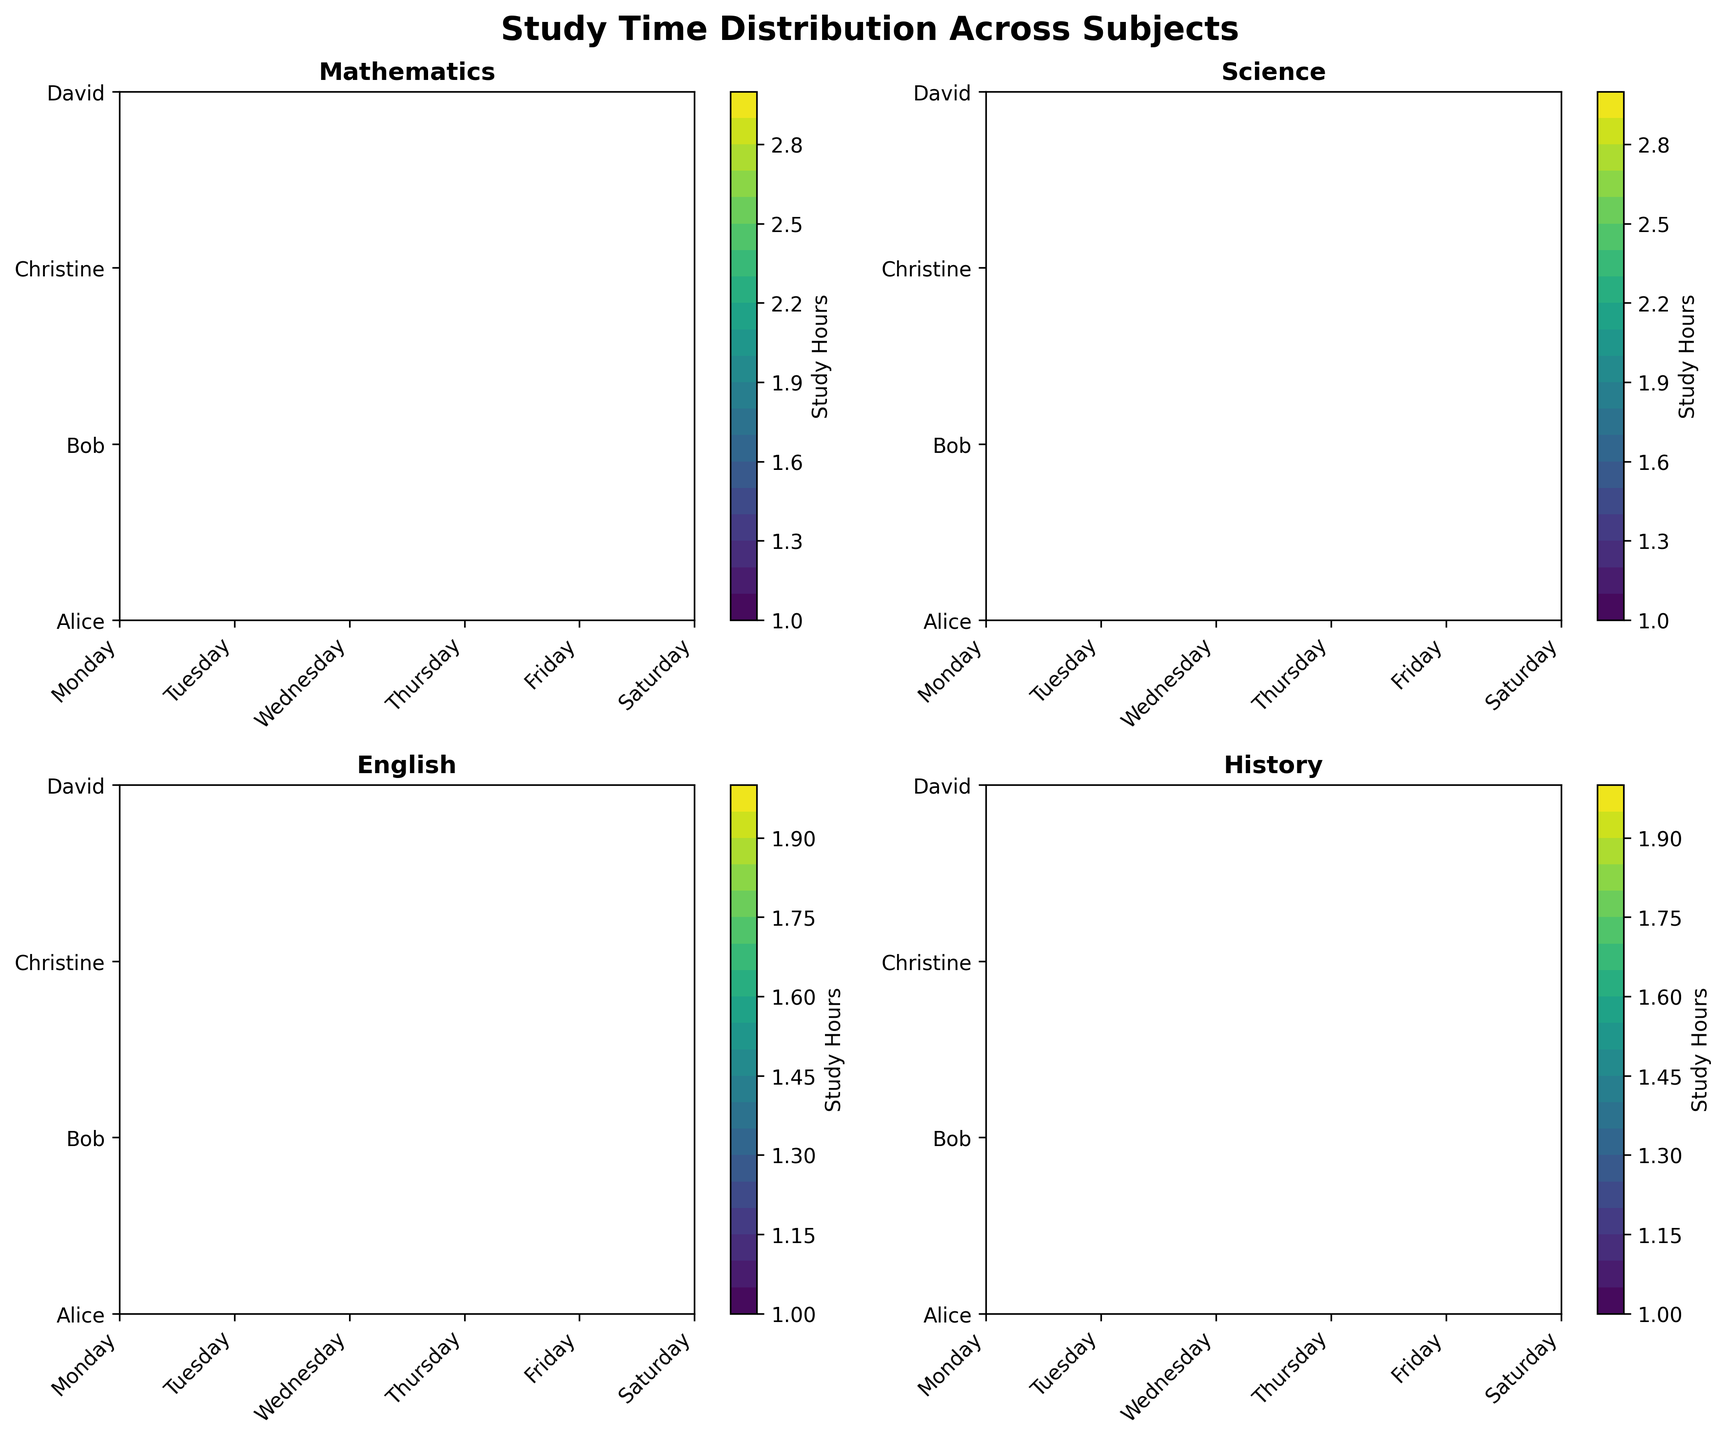What is the title of the figure? The title is usually placed at the top of the figure. Here, we can see that it says "Study Time Distribution Across Subjects," indicating the topic of the figure
Answer: Study Time Distribution Across Subjects Which subject panel has the highest study hours on Monday for the most students? By observing the contour intensity in the Monday column across all subject panels, we can identify which subject has the highest contour value. In this case, both Mathematics and Science panels have high study hours on Monday for multiple students
Answer: Mathematics and Science How many subjects are depicted in the figure? Each subplot shows a different subject, and there are four subplots. By counting these subplots, we conclude that there are four subjects represented
Answer: Four In which subject is the study time distribution the most uniform across the days? We need to look at the contour plots and see where the contour lines are most evenly spaced and the color distribution is consistent. The Mathematics panel looks the most uniform in terms of color and spacing
Answer: Mathematics Which subject shows the highest variability in study hours among students? By examining the contour plots, we can detect variability through inconsistencies and variations in the contour levels. History seems to have more variability in study hours based on the contour data
Answer: History Who studied the least amount of hours for English on Friday? We need to look at the English panel and find the contour values for Friday. By checking the contour levels associated with each student, we can see Christine studied the least amount of hours
Answer: Christine Which student has the most consistent study hours across all days for Science? By comparing the rows in the Science panel, we need to find the student whose contour levels are relatively flat and uniform across the days. Alice demonstrates the most consistent study hours
Answer: Alice On which day did Alice study Mathematics the longest? To answer this, observe the Mathematics panel and track Alice's row for the highest value. She studied the longest (2 hours) on Monday and Saturday
Answer: Monday and Saturday Which student dedicated the most hours to History on Tuesday? By examining the History panel and identifying which student has the highest contour level for Tuesday, we find that Bob dedicated 2 hours
Answer: Bob What is the overall trend in study time for Mathematics on Saturday? By examining the Mathematics panel for Saturday, the majority of students have higher contours, suggesting an uptick in study hours (1.5 to 2 hours) for Mathematics
Answer: Increasing 